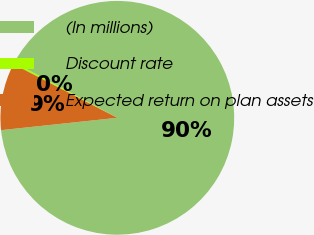Convert chart. <chart><loc_0><loc_0><loc_500><loc_500><pie_chart><fcel>(In millions)<fcel>Discount rate<fcel>Expected return on plan assets<nl><fcel>90.47%<fcel>0.25%<fcel>9.27%<nl></chart> 